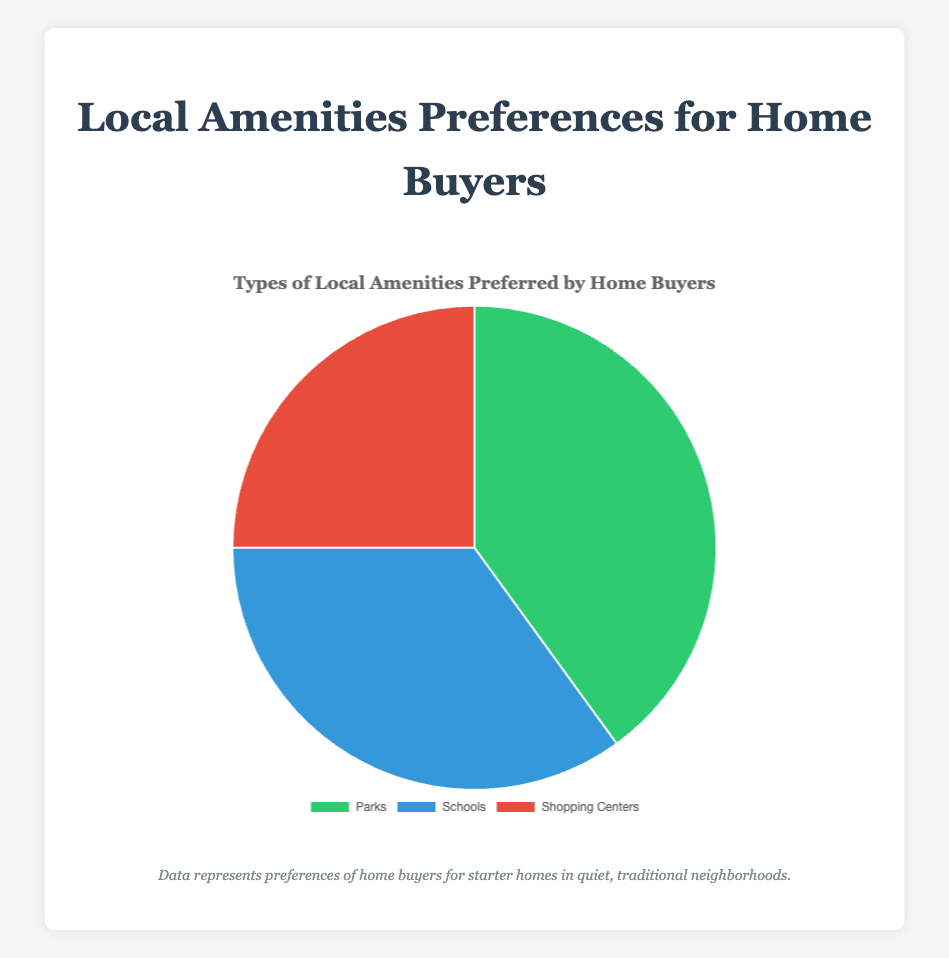Which type of local amenity is preferred the most by home buyers? By looking at the pie chart, observe the slice with the largest proportion. Parks have the largest slice with a percentage of 40%.
Answer: Parks What percentage of home buyers prefer schools as a local amenity? Referring to the pie chart, find the percentage labeled for Schools. Schools are preferred by 35% of home buyers.
Answer: 35% Which local amenity is the least preferred by home buyers? Examine the pie chart and identify the slice with the smallest proportion. The smallest slice corresponds to Shopping Centers, preferred by 25%.
Answer: Shopping Centers How much more popular are Parks compared to Shopping Centers in terms of percentage points? Calculate the difference in percentage between Parks and Shopping Centers: 40% (Parks) - 25% (Shopping Centers). This equals 15 percentage points.
Answer: 15 percentage points What is the combined percentage of home buyers who prefer either Parks or Schools? Add the percentages for Parks and Schools: 40% (Parks) + 35% (Schools). The total percentage is 75%.
Answer: 75% What is the average percentage preference for the three local amenities? Calculate the average by summing the percentages and dividing by the number of amenities: (40 + 35 + 25) / 3. The average percentage is (100 / 3) which equals approximately 33.33%.
Answer: 33.33% Compare the preference for Schools to Shopping Centers. By how many percentage points is one more preferred than the other? Calculate the difference in percentages between Schools and Shopping Centers: 35% (Schools) - 25% (Shopping Centers). Schools are preferred by 10 percentage points more than Shopping Centers.
Answer: 10 percentage points What is the ratio of home buyers who prefer Parks to those who prefer Schools? Use the percentages to calculate the ratio: 40% (Parks) / 35% (Schools). Simplify the ratio to 8:7.
Answer: 8:7 